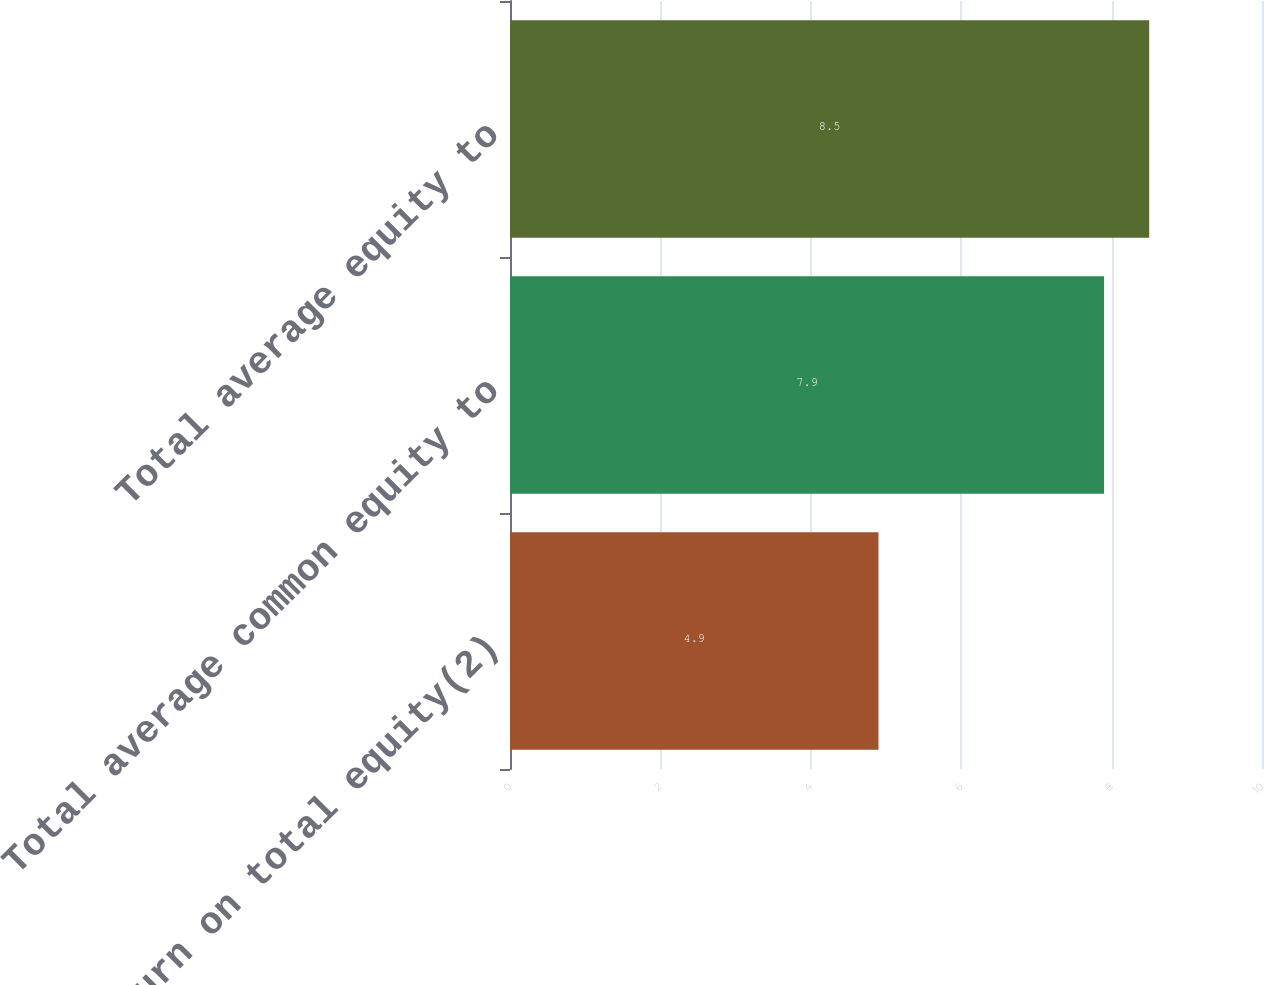<chart> <loc_0><loc_0><loc_500><loc_500><bar_chart><fcel>Return on total equity(2)<fcel>Total average common equity to<fcel>Total average equity to<nl><fcel>4.9<fcel>7.9<fcel>8.5<nl></chart> 